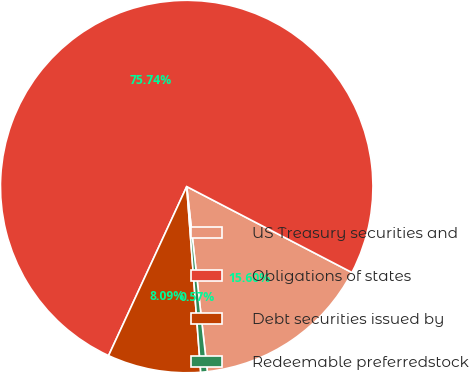Convert chart. <chart><loc_0><loc_0><loc_500><loc_500><pie_chart><fcel>US Treasury securities and<fcel>Obligations of states<fcel>Debt securities issued by<fcel>Redeemable preferredstock<nl><fcel>15.6%<fcel>75.74%<fcel>8.09%<fcel>0.57%<nl></chart> 